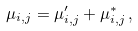Convert formula to latex. <formula><loc_0><loc_0><loc_500><loc_500>\mu _ { i , j } = \mu ^ { \prime } _ { i , j } + \mu ^ { * } _ { i , j } \, ,</formula> 